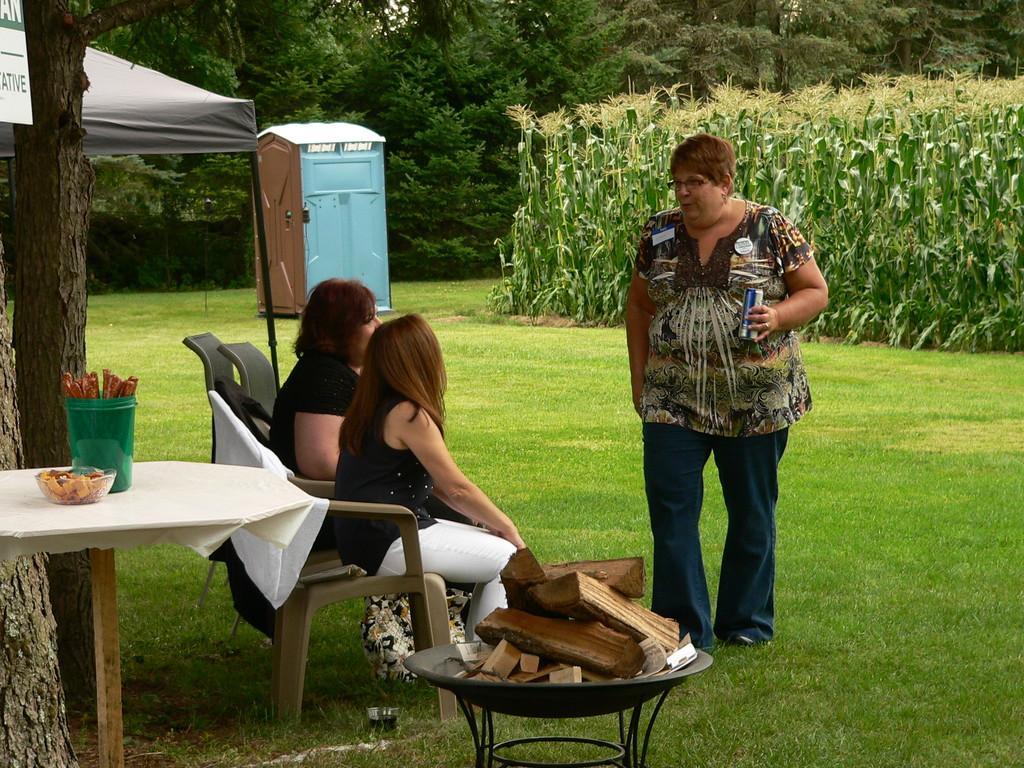Describe this image in one or two sentences. There are two women sitting on the chair and a woman is standing by holding red bull in her hand. There are food items on the table which is on the left and small wood pieces in a stand in the middle. In the background there are trees,rent,a store and maize field. 